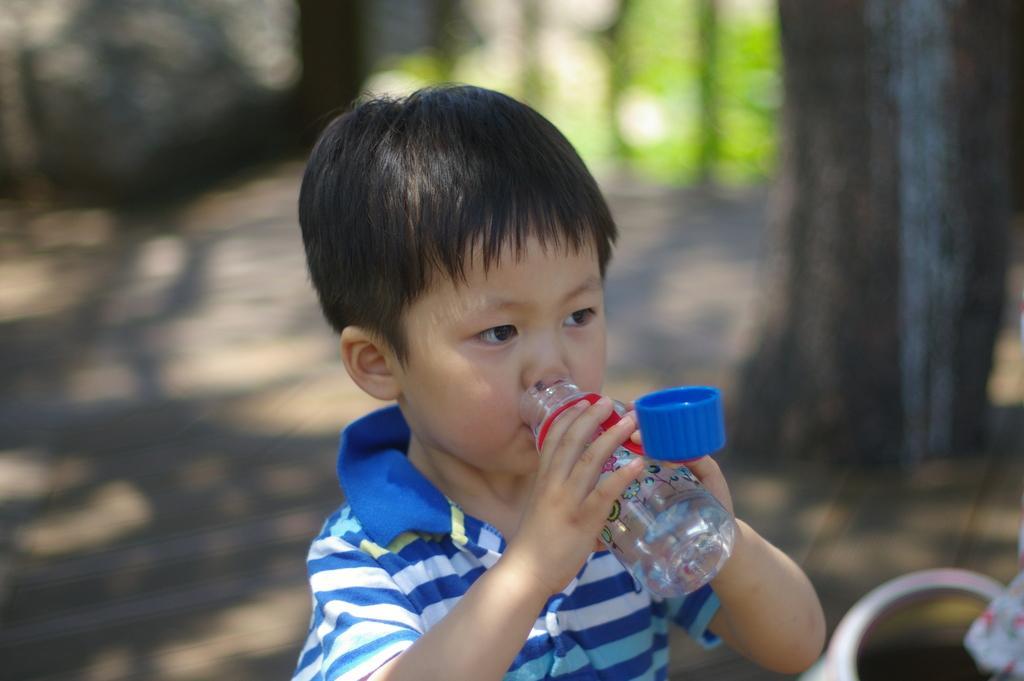How would you summarize this image in a sentence or two? Background is blurry. We can see trees. We can see a boy holding a bottle in his hands and drinking water. This is a cap. 